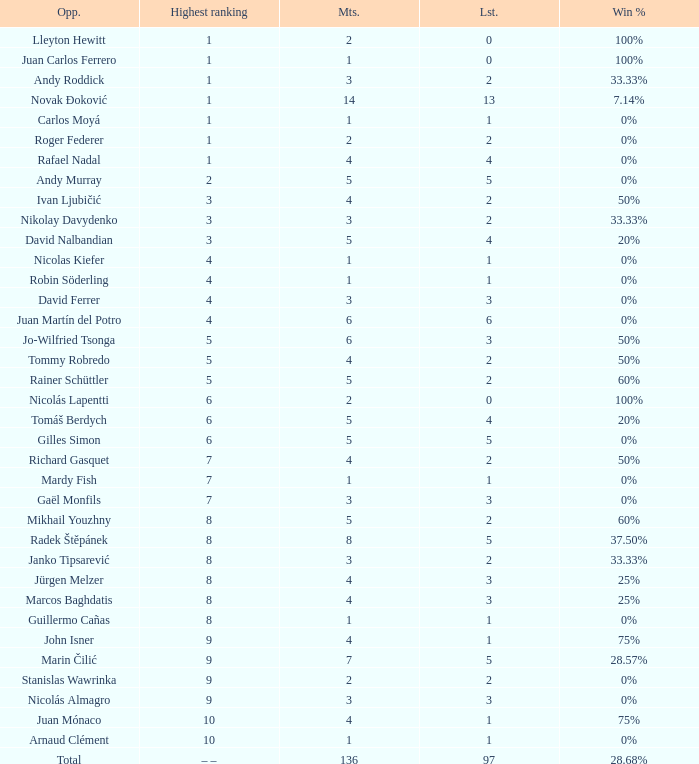What is the total number of Lost for the Highest Ranking of – –? 1.0. 